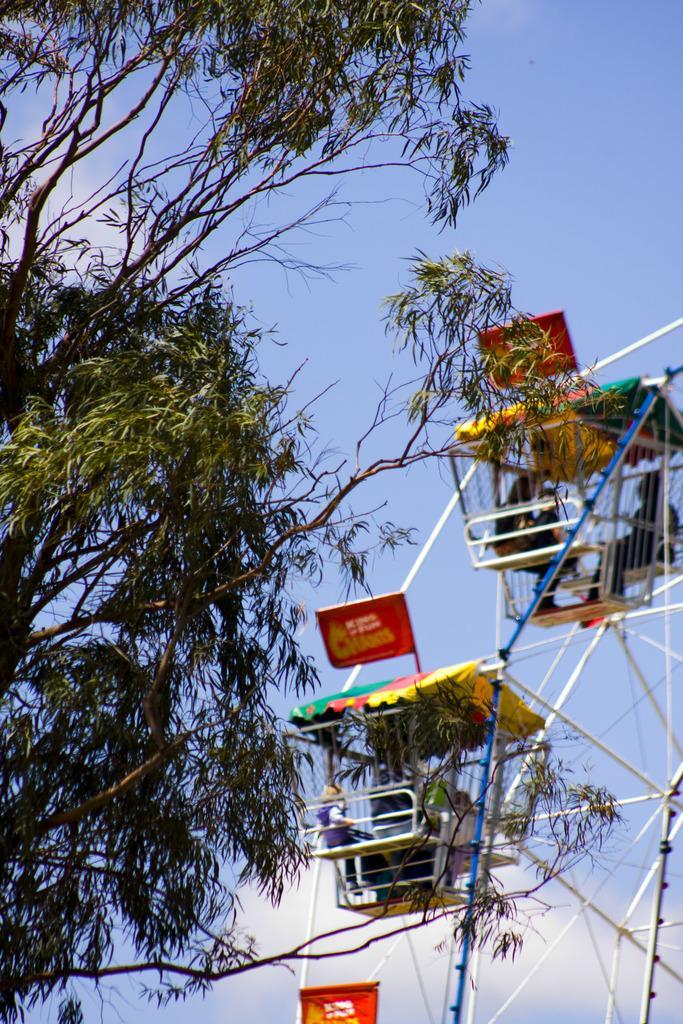Please provide a concise description of this image. In this picture we can see a giant wheel and people and in the background we can see trees and the sky. 